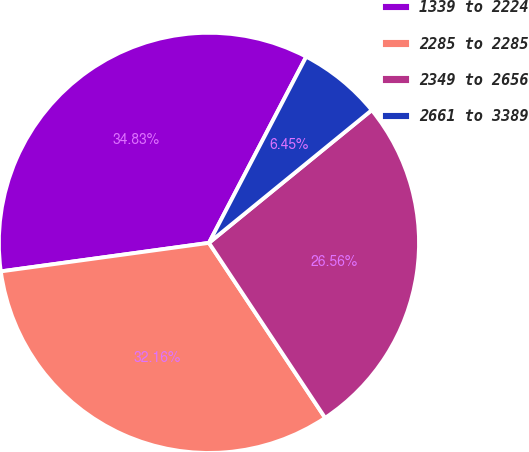Convert chart. <chart><loc_0><loc_0><loc_500><loc_500><pie_chart><fcel>1339 to 2224<fcel>2285 to 2285<fcel>2349 to 2656<fcel>2661 to 3389<nl><fcel>34.83%<fcel>32.16%<fcel>26.56%<fcel>6.45%<nl></chart> 